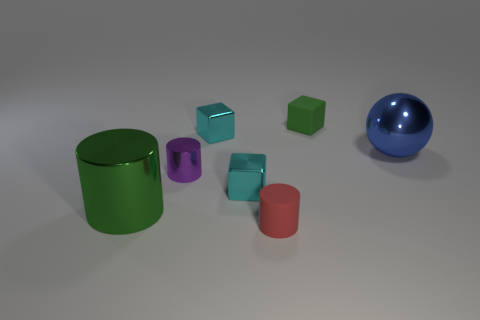Subtract all cylinders. How many objects are left? 4 Add 3 purple cylinders. How many objects exist? 10 Subtract all tiny matte cylinders. Subtract all tiny purple things. How many objects are left? 5 Add 3 small cyan metallic cubes. How many small cyan metallic cubes are left? 5 Add 2 blue spheres. How many blue spheres exist? 3 Subtract 0 green spheres. How many objects are left? 7 